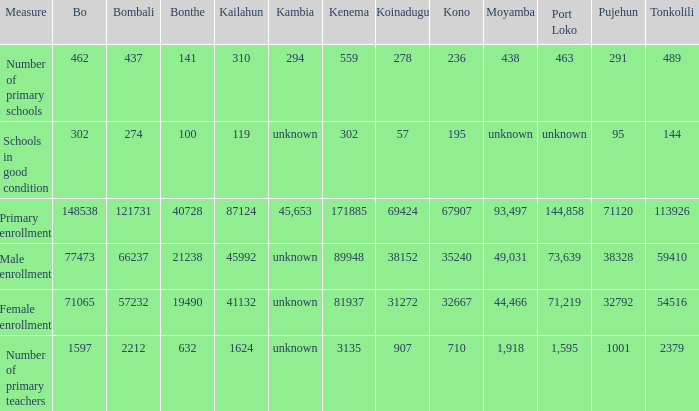What is the lowest number associated with Tonkolili? 144.0. 